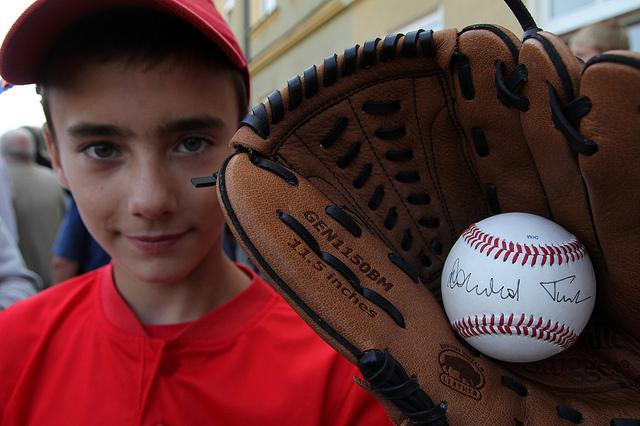What is this person holding?
Write a very short answer. Baseball. How big is the glove?
Keep it brief. Big. What is on the ball?
Write a very short answer. Autograph. 